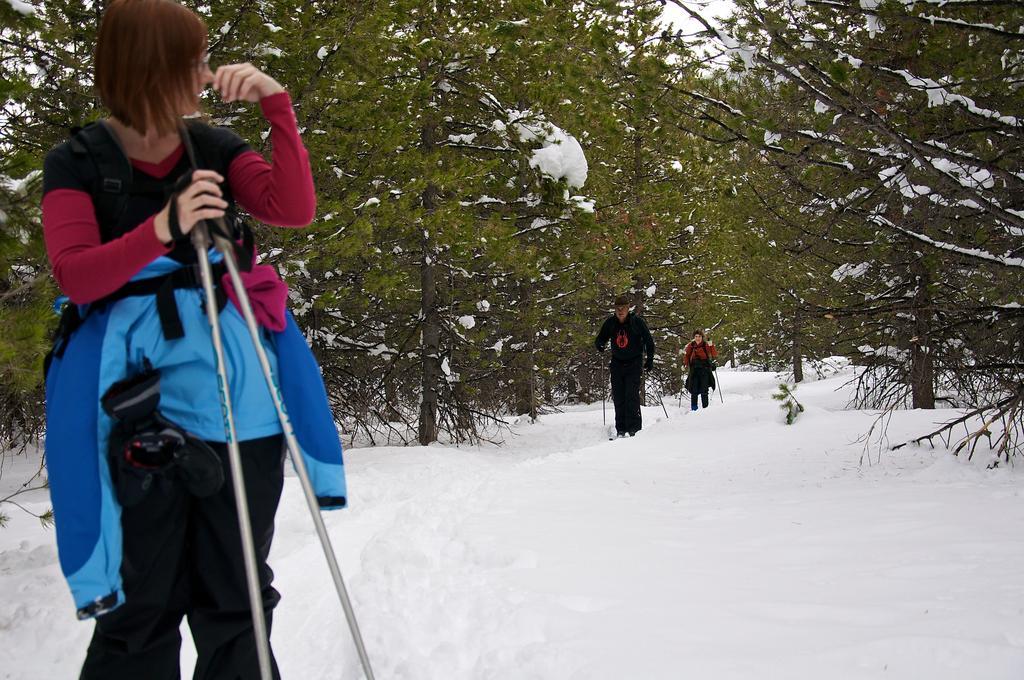Please provide a concise description of this image. In the foreground of the image there is a person standing. At the bottom of the image there is snow. In the background of the image there are trees and persons. 